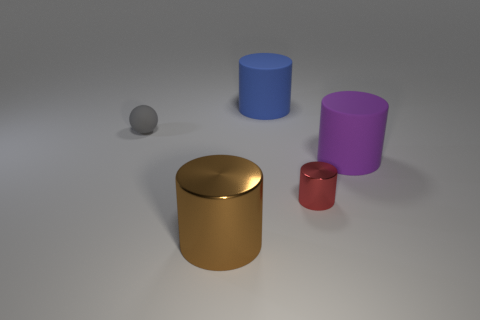Add 1 large red matte cylinders. How many objects exist? 6 Subtract all big cylinders. How many cylinders are left? 1 Subtract all purple cylinders. How many cylinders are left? 3 Subtract 2 cylinders. How many cylinders are left? 2 Subtract all cylinders. How many objects are left? 1 Add 4 small red metal cylinders. How many small red metal cylinders exist? 5 Subtract 1 purple cylinders. How many objects are left? 4 Subtract all brown spheres. Subtract all brown cylinders. How many spheres are left? 1 Subtract all brown cylinders. Subtract all cylinders. How many objects are left? 0 Add 4 blue matte objects. How many blue matte objects are left? 5 